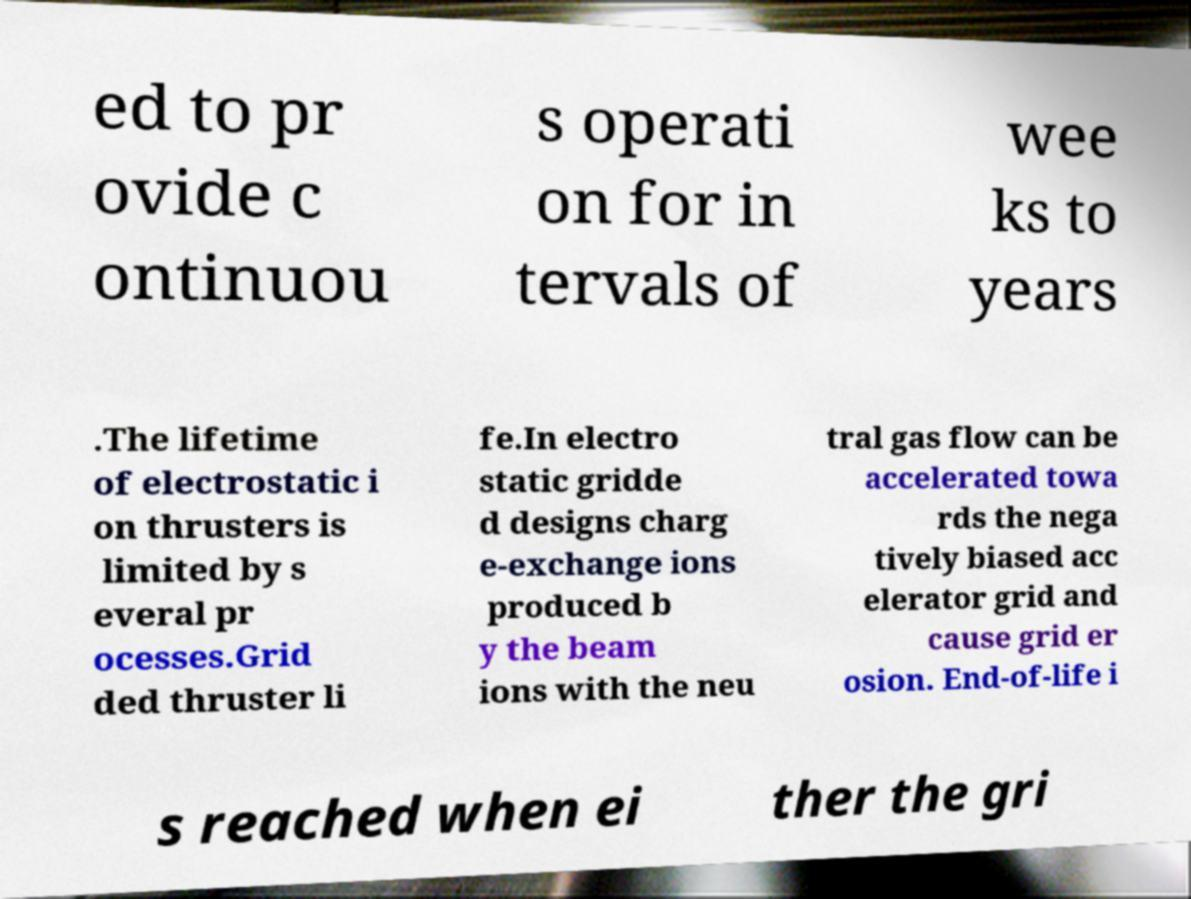Please identify and transcribe the text found in this image. ed to pr ovide c ontinuou s operati on for in tervals of wee ks to years .The lifetime of electrostatic i on thrusters is limited by s everal pr ocesses.Grid ded thruster li fe.In electro static gridde d designs charg e-exchange ions produced b y the beam ions with the neu tral gas flow can be accelerated towa rds the nega tively biased acc elerator grid and cause grid er osion. End-of-life i s reached when ei ther the gri 